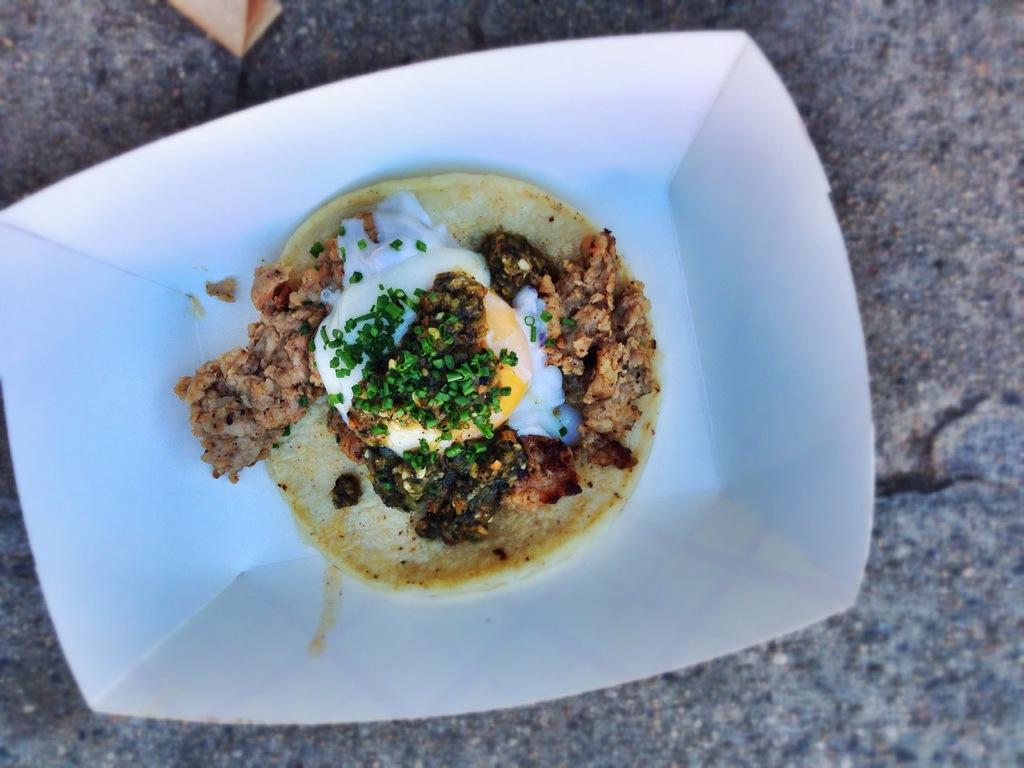How would you summarize this image in a sentence or two? In this image I can see the plate with food. The plate is in white color and the food is in green, brown, white and cream color. The plate is on the ash color surface. 